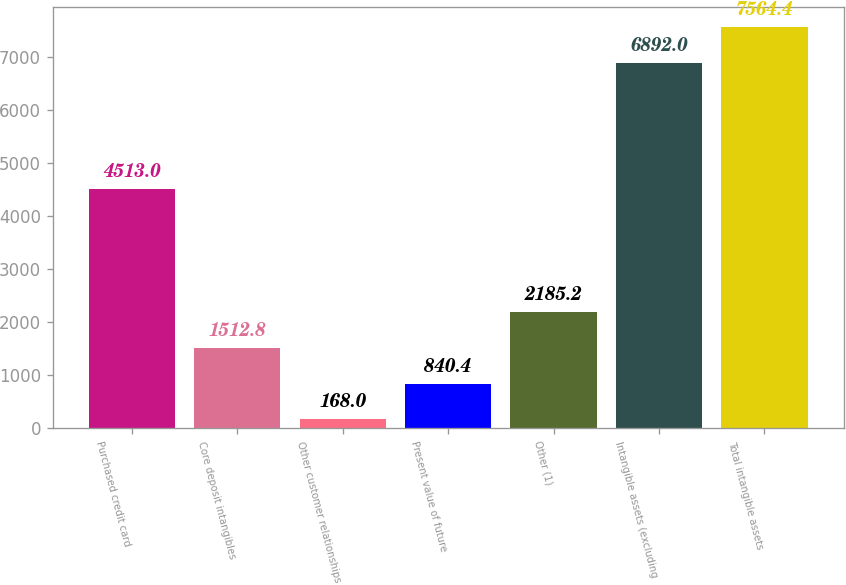Convert chart to OTSL. <chart><loc_0><loc_0><loc_500><loc_500><bar_chart><fcel>Purchased credit card<fcel>Core deposit intangibles<fcel>Other customer relationships<fcel>Present value of future<fcel>Other (1)<fcel>Intangible assets (excluding<fcel>Total intangible assets<nl><fcel>4513<fcel>1512.8<fcel>168<fcel>840.4<fcel>2185.2<fcel>6892<fcel>7564.4<nl></chart> 